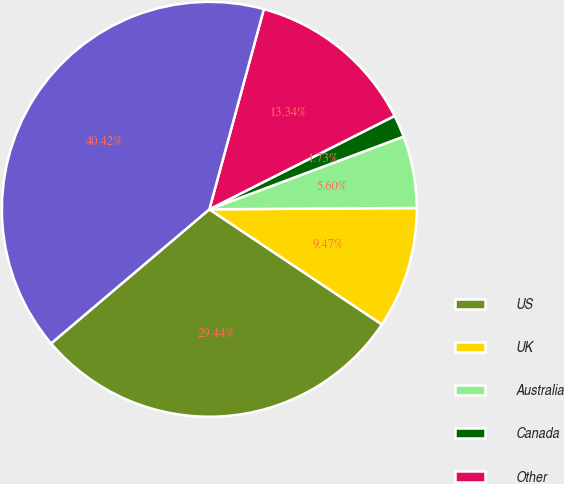<chart> <loc_0><loc_0><loc_500><loc_500><pie_chart><fcel>US<fcel>UK<fcel>Australia<fcel>Canada<fcel>Other<fcel>Total operating revenue<nl><fcel>29.45%<fcel>9.47%<fcel>5.6%<fcel>1.73%<fcel>13.34%<fcel>40.43%<nl></chart> 